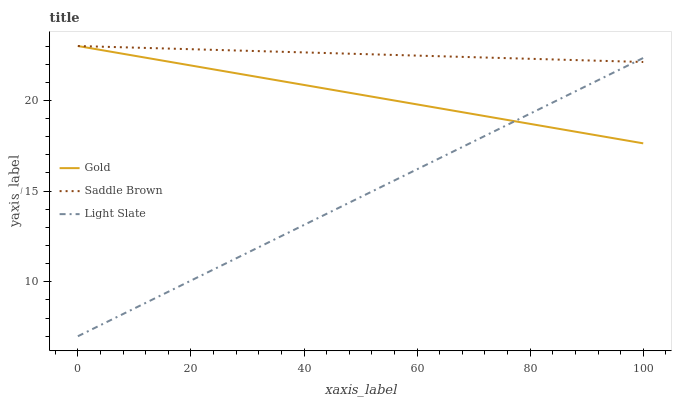Does Light Slate have the minimum area under the curve?
Answer yes or no. Yes. Does Saddle Brown have the maximum area under the curve?
Answer yes or no. Yes. Does Gold have the minimum area under the curve?
Answer yes or no. No. Does Gold have the maximum area under the curve?
Answer yes or no. No. Is Light Slate the smoothest?
Answer yes or no. Yes. Is Gold the roughest?
Answer yes or no. Yes. Is Saddle Brown the smoothest?
Answer yes or no. No. Is Saddle Brown the roughest?
Answer yes or no. No. Does Gold have the lowest value?
Answer yes or no. No. Does Gold have the highest value?
Answer yes or no. Yes. Does Light Slate intersect Saddle Brown?
Answer yes or no. Yes. Is Light Slate less than Saddle Brown?
Answer yes or no. No. Is Light Slate greater than Saddle Brown?
Answer yes or no. No. 